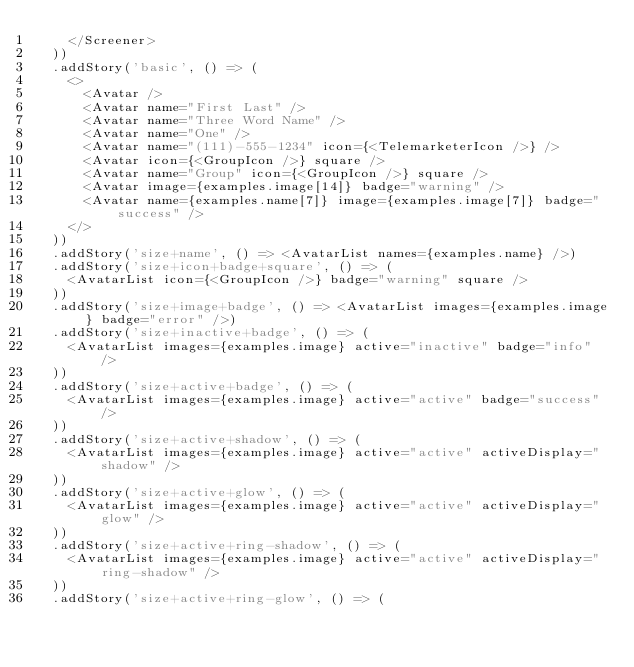<code> <loc_0><loc_0><loc_500><loc_500><_TypeScript_>    </Screener>
  ))
  .addStory('basic', () => (
    <>
      <Avatar />
      <Avatar name="First Last" />
      <Avatar name="Three Word Name" />
      <Avatar name="One" />
      <Avatar name="(111)-555-1234" icon={<TelemarketerIcon />} />
      <Avatar icon={<GroupIcon />} square />
      <Avatar name="Group" icon={<GroupIcon />} square />
      <Avatar image={examples.image[14]} badge="warning" />
      <Avatar name={examples.name[7]} image={examples.image[7]} badge="success" />
    </>
  ))
  .addStory('size+name', () => <AvatarList names={examples.name} />)
  .addStory('size+icon+badge+square', () => (
    <AvatarList icon={<GroupIcon />} badge="warning" square />
  ))
  .addStory('size+image+badge', () => <AvatarList images={examples.image} badge="error" />)
  .addStory('size+inactive+badge', () => (
    <AvatarList images={examples.image} active="inactive" badge="info" />
  ))
  .addStory('size+active+badge', () => (
    <AvatarList images={examples.image} active="active" badge="success" />
  ))
  .addStory('size+active+shadow', () => (
    <AvatarList images={examples.image} active="active" activeDisplay="shadow" />
  ))
  .addStory('size+active+glow', () => (
    <AvatarList images={examples.image} active="active" activeDisplay="glow" />
  ))
  .addStory('size+active+ring-shadow', () => (
    <AvatarList images={examples.image} active="active" activeDisplay="ring-shadow" />
  ))
  .addStory('size+active+ring-glow', () => (</code> 